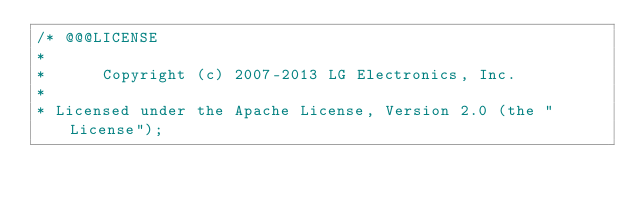Convert code to text. <code><loc_0><loc_0><loc_500><loc_500><_C_>/* @@@LICENSE
*
*      Copyright (c) 2007-2013 LG Electronics, Inc.
*
* Licensed under the Apache License, Version 2.0 (the "License");</code> 